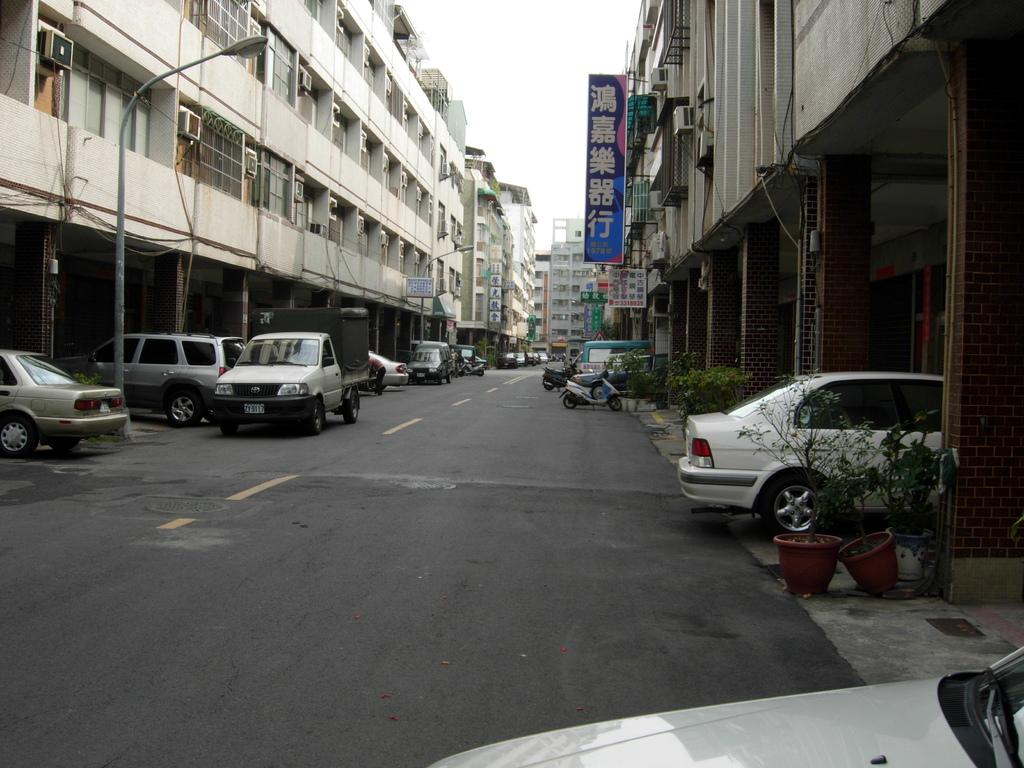What is the main feature in the center of the image? There is a road in the center of the image. What can be seen on the road? There are vehicles on the road. What surrounds the road in the image? There are buildings on both sides of the image. What is the purpose of the object near the road? There is a street light in the image, which is used to illuminate the road at night. What type of vegetation is present in the image? There are plants in the image. Can you see a crook holding a gun in the image? There is no crook or gun present in the image. What type of tree is growing near the street light? There is no tree present in the image. 